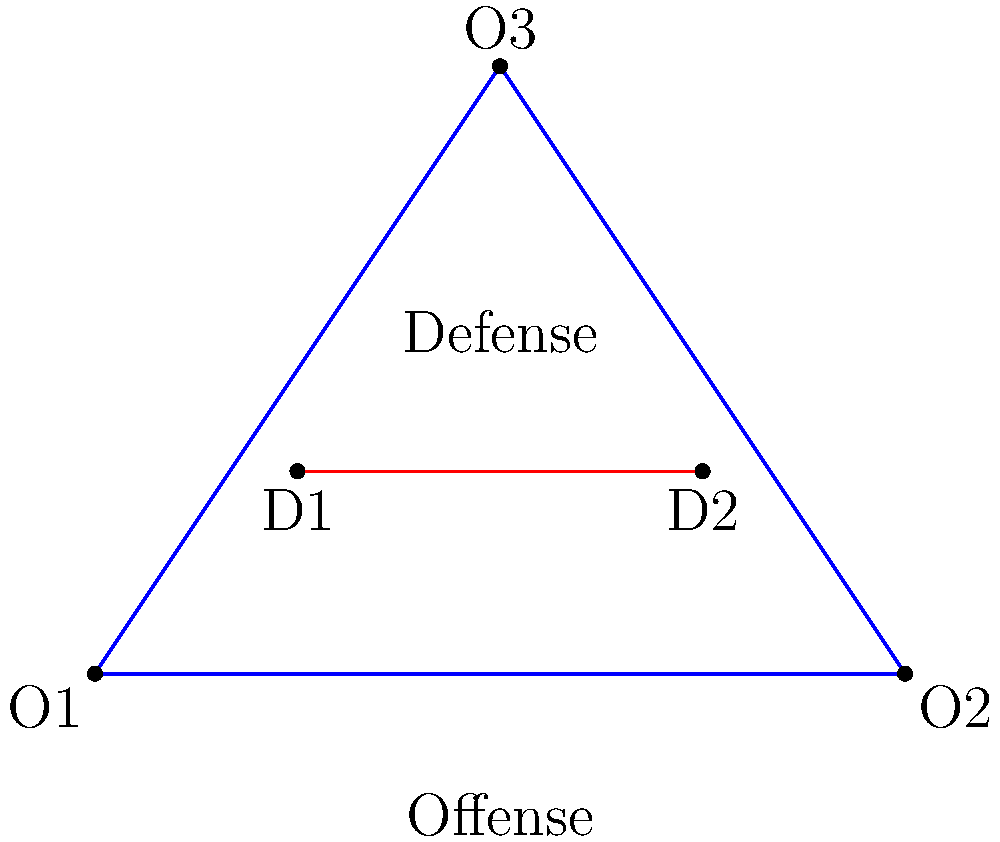In the diagram above, the blue triangle represents an offensive formation with three players (O1, O2, O3), while the red line represents a defensive line with two players (D1, D2). Which of the following adjustments to the defensive line would provide the best coverage against the offensive formation?

a) Move D1 closer to O1
b) Move D2 closer to O2
c) Shift both D1 and D2 towards the center
d) Add a third defensive player at the midpoint of the red line To solve this problem, we need to analyze the geometric relationships between the offensive and defensive formations:

1. The offensive formation (blue triangle) covers a larger area than the current defensive line (red line).

2. The offensive players (O1, O2, O3) form an isosceles triangle, with O3 at the apex.

3. The current defensive line (D1-D2) is parallel to the base of the offensive triangle (O1-O2).

4. There's a significant gap between the defensive line and O3, leaving that player open.

5. Adding a third defensive player at the midpoint of the red line would create a triangle formation for the defense, mirroring the offensive setup.

6. This new defensive triangle would provide better coverage against all three offensive players:
   - It would maintain coverage of O1 and O2.
   - The new player would be positioned to defend against O3.

7. The triangular formation allows for more flexibility in responding to offensive movements compared to a linear formation.

Therefore, the best adjustment would be to add a third defensive player at the midpoint of the red line, creating a triangular defensive formation that mirrors and counters the offensive setup.
Answer: d) Add a third defensive player at the midpoint of the red line 